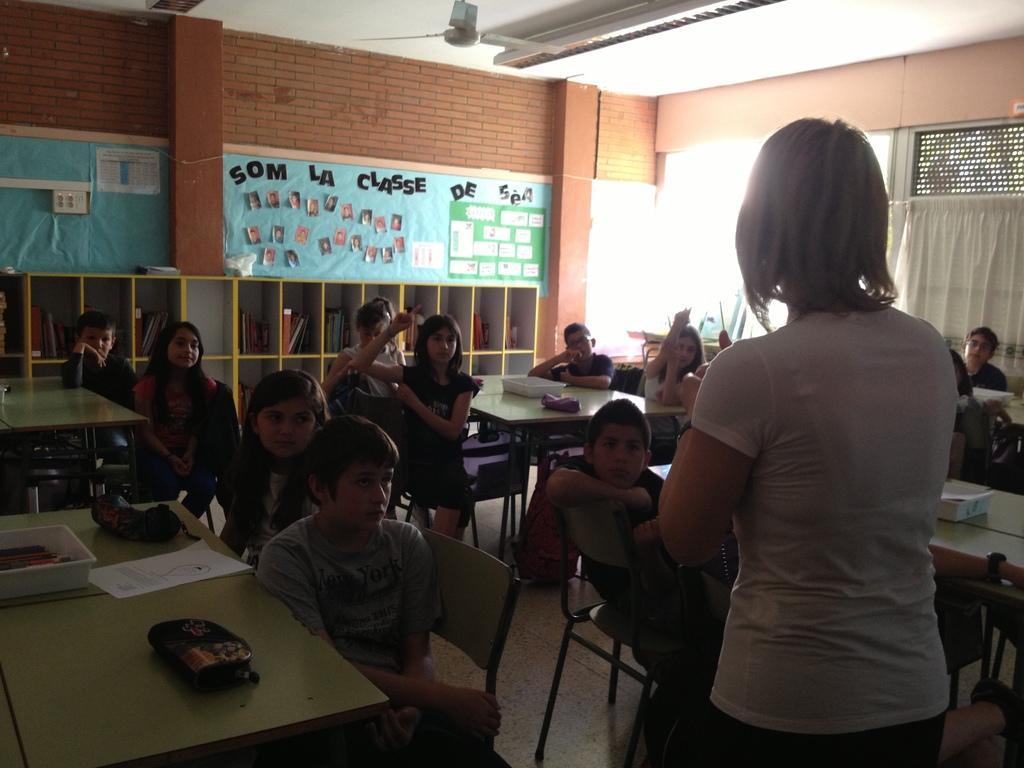Please provide a concise description of this image. This image look like it is taken in a class room. There are many people in this image. All are sitting in the chairs near the tables. In the front, the woman is standing. She is wearing a white color t-shirt. To the left, on the table there is a paper a tray. In the background there is a wall on which some pictures are posted. 